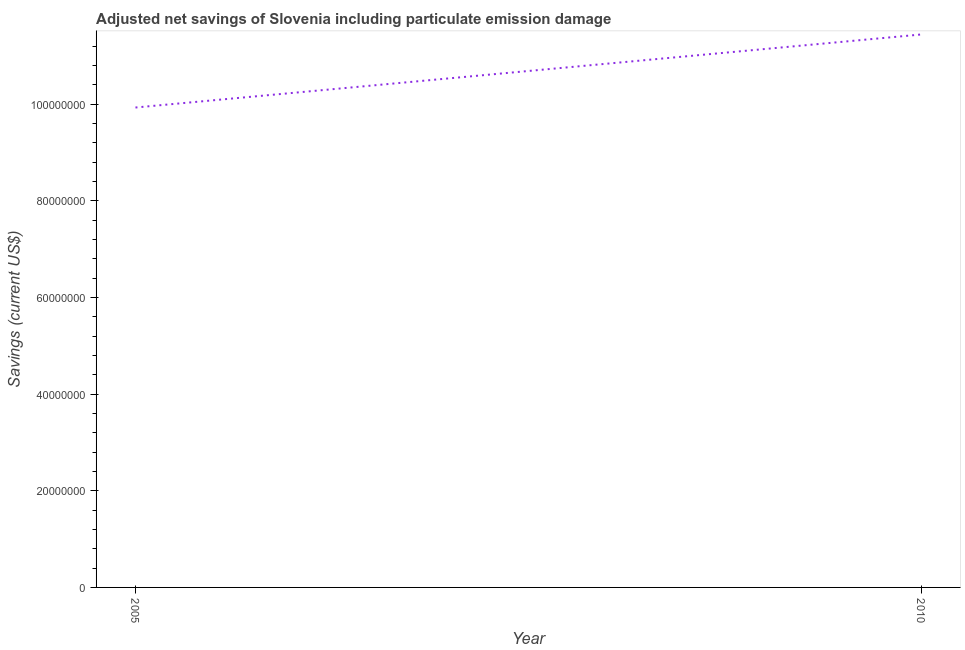What is the adjusted net savings in 2010?
Offer a terse response. 1.14e+08. Across all years, what is the maximum adjusted net savings?
Give a very brief answer. 1.14e+08. Across all years, what is the minimum adjusted net savings?
Your answer should be compact. 9.93e+07. In which year was the adjusted net savings maximum?
Keep it short and to the point. 2010. What is the sum of the adjusted net savings?
Offer a very short reply. 2.14e+08. What is the difference between the adjusted net savings in 2005 and 2010?
Offer a very short reply. -1.51e+07. What is the average adjusted net savings per year?
Give a very brief answer. 1.07e+08. What is the median adjusted net savings?
Your answer should be compact. 1.07e+08. In how many years, is the adjusted net savings greater than 60000000 US$?
Provide a succinct answer. 2. Do a majority of the years between 2010 and 2005 (inclusive) have adjusted net savings greater than 52000000 US$?
Provide a succinct answer. No. What is the ratio of the adjusted net savings in 2005 to that in 2010?
Make the answer very short. 0.87. In how many years, is the adjusted net savings greater than the average adjusted net savings taken over all years?
Your answer should be very brief. 1. What is the difference between two consecutive major ticks on the Y-axis?
Offer a very short reply. 2.00e+07. Are the values on the major ticks of Y-axis written in scientific E-notation?
Ensure brevity in your answer.  No. Does the graph contain any zero values?
Ensure brevity in your answer.  No. Does the graph contain grids?
Keep it short and to the point. No. What is the title of the graph?
Ensure brevity in your answer.  Adjusted net savings of Slovenia including particulate emission damage. What is the label or title of the X-axis?
Your answer should be very brief. Year. What is the label or title of the Y-axis?
Provide a succinct answer. Savings (current US$). What is the Savings (current US$) in 2005?
Your answer should be very brief. 9.93e+07. What is the Savings (current US$) in 2010?
Provide a short and direct response. 1.14e+08. What is the difference between the Savings (current US$) in 2005 and 2010?
Keep it short and to the point. -1.51e+07. What is the ratio of the Savings (current US$) in 2005 to that in 2010?
Offer a very short reply. 0.87. 